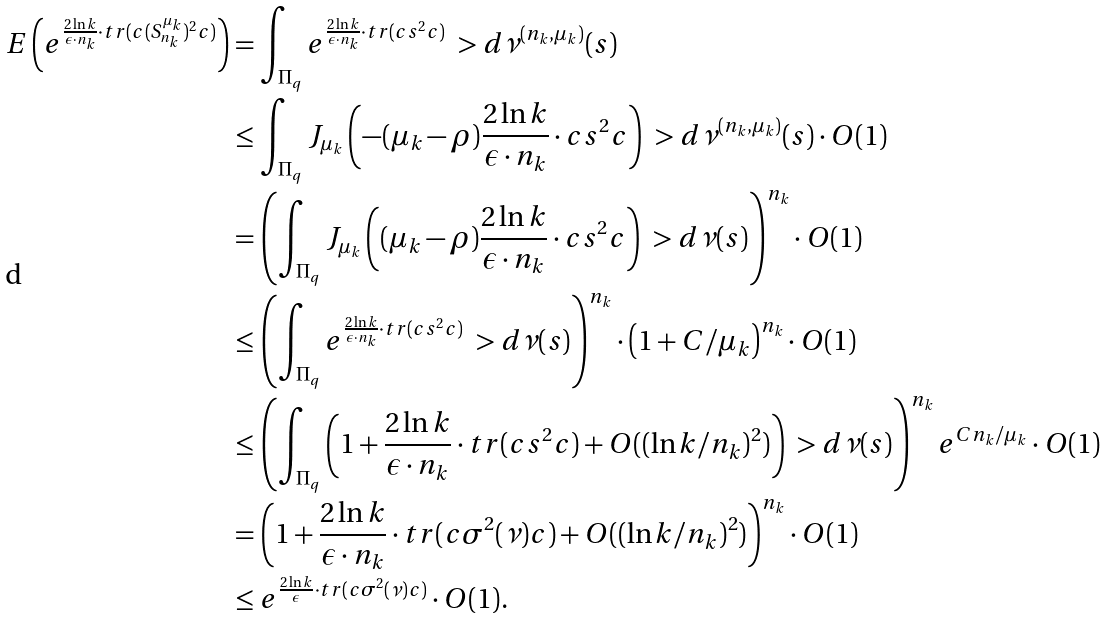Convert formula to latex. <formula><loc_0><loc_0><loc_500><loc_500>E \left ( e ^ { \frac { 2 \ln k } { \epsilon \cdot n _ { k } } \cdot t r ( c ( S _ { n _ { k } } ^ { \mu _ { k } } ) ^ { 2 } c ) } \right ) & = \int _ { \Pi _ { q } } e ^ { \frac { 2 \ln k } { \epsilon \cdot n _ { k } } \cdot t r ( c s ^ { 2 } c ) } \ > d \nu ^ { ( n _ { k } , \mu _ { k } ) } ( s ) \\ & \leq \int _ { \Pi _ { q } } J _ { \mu _ { k } } \left ( - ( \mu _ { k } - \rho ) \frac { 2 \ln k } { \epsilon \cdot n _ { k } } \cdot c s ^ { 2 } c \right ) \ > d \nu ^ { ( n _ { k } , \mu _ { k } ) } ( s ) \cdot O ( 1 ) \\ & = \left ( \int _ { \Pi _ { q } } J _ { \mu _ { k } } \left ( ( \mu _ { k } - \rho ) \frac { 2 \ln k } { \epsilon \cdot n _ { k } } \cdot c s ^ { 2 } c \right ) \ > d \nu ( s ) \right ) ^ { n _ { k } } \cdot O ( 1 ) \\ & \leq \left ( \int _ { \Pi _ { q } } e ^ { \frac { 2 \ln k } { \epsilon \cdot n _ { k } } \cdot t r ( c s ^ { 2 } c ) } \ > d \nu ( s ) \right ) ^ { n _ { k } } \cdot \left ( 1 + C / \mu _ { k } \right ) ^ { n _ { k } } \cdot O ( 1 ) \\ & \leq \left ( \int _ { \Pi _ { q } } \left ( 1 + \frac { 2 \ln k } { \epsilon \cdot n _ { k } } \cdot t r ( c s ^ { 2 } c ) + O ( ( \ln k / n _ { k } ) ^ { 2 } ) \right ) \ > d \nu ( s ) \right ) ^ { n _ { k } } e ^ { C n _ { k } / \mu _ { k } } \cdot O ( 1 ) \\ & = \left ( 1 + \frac { 2 \ln k } { \epsilon \cdot n _ { k } } \cdot t r ( c \sigma ^ { 2 } ( \nu ) c ) + O ( ( \ln k / n _ { k } ) ^ { 2 } ) \right ) ^ { n _ { k } } \cdot O ( 1 ) \\ & \leq e ^ { \frac { 2 \ln k } { \epsilon } \cdot t r ( c \sigma ^ { 2 } ( \nu ) c ) } \cdot O ( 1 ) .</formula> 